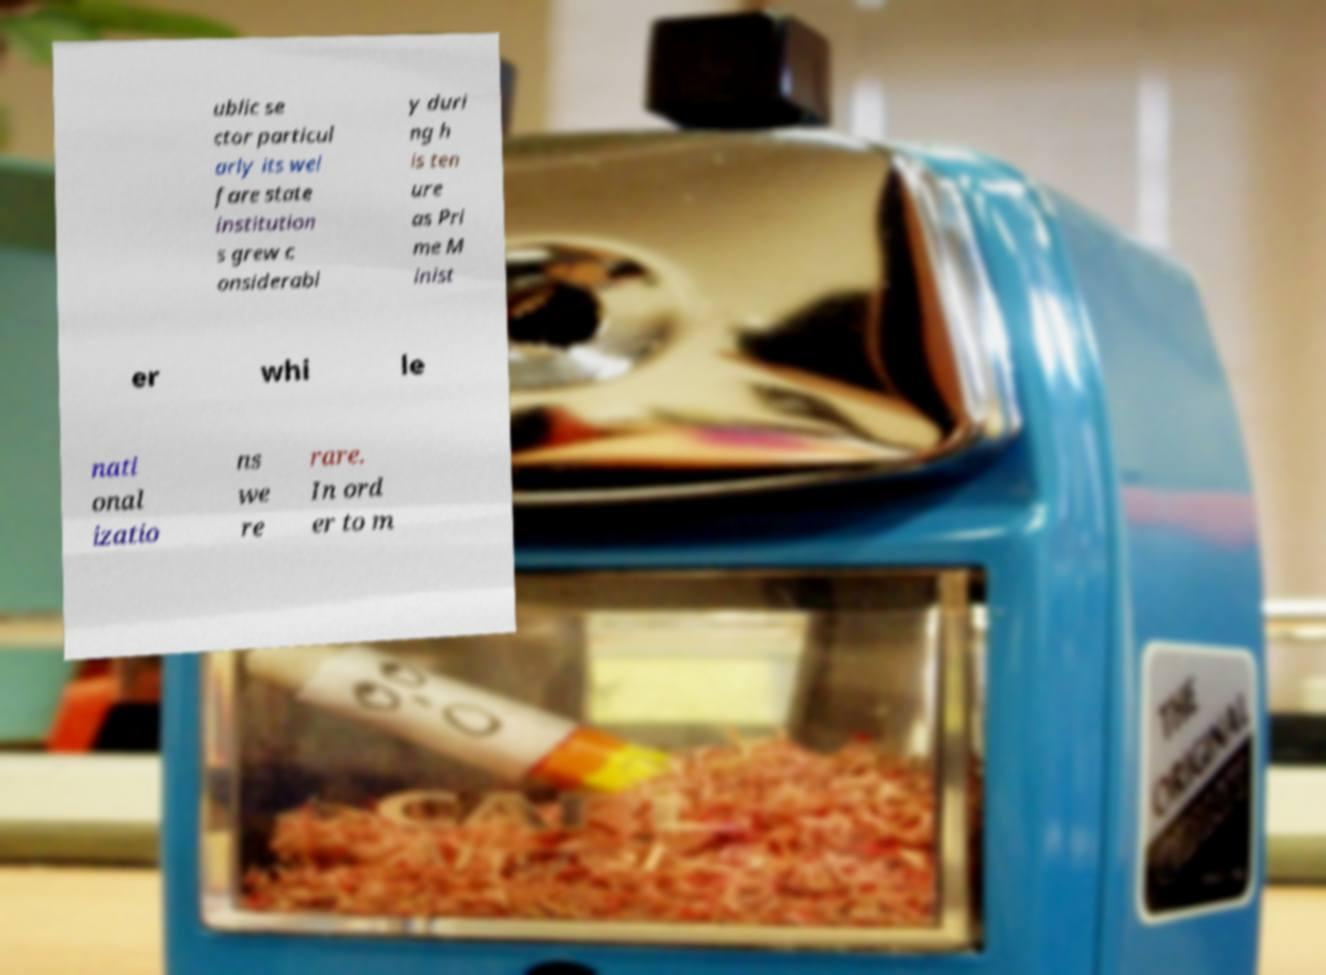For documentation purposes, I need the text within this image transcribed. Could you provide that? ublic se ctor particul arly its wel fare state institution s grew c onsiderabl y duri ng h is ten ure as Pri me M inist er whi le nati onal izatio ns we re rare. In ord er to m 